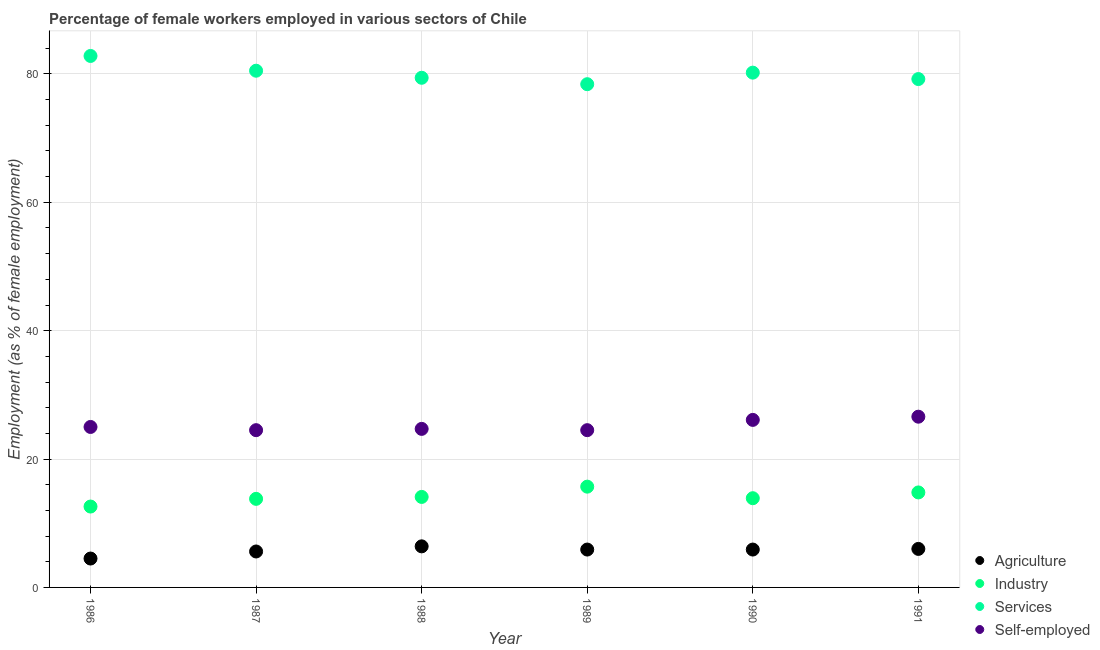What is the percentage of female workers in industry in 1987?
Provide a succinct answer. 13.8. Across all years, what is the maximum percentage of female workers in agriculture?
Offer a terse response. 6.4. Across all years, what is the minimum percentage of female workers in industry?
Provide a succinct answer. 12.6. In which year was the percentage of female workers in industry maximum?
Provide a short and direct response. 1989. What is the total percentage of female workers in industry in the graph?
Give a very brief answer. 84.9. What is the difference between the percentage of female workers in agriculture in 1986 and that in 1989?
Ensure brevity in your answer.  -1.4. What is the difference between the percentage of female workers in agriculture in 1989 and the percentage of female workers in industry in 1987?
Provide a succinct answer. -7.9. What is the average percentage of female workers in services per year?
Make the answer very short. 80.08. In the year 1987, what is the difference between the percentage of female workers in agriculture and percentage of female workers in services?
Make the answer very short. -74.9. What is the ratio of the percentage of female workers in industry in 1986 to that in 1987?
Provide a succinct answer. 0.91. Is the percentage of self employed female workers in 1986 less than that in 1989?
Your answer should be compact. No. What is the difference between the highest and the second highest percentage of self employed female workers?
Provide a succinct answer. 0.5. What is the difference between the highest and the lowest percentage of female workers in industry?
Offer a terse response. 3.1. In how many years, is the percentage of self employed female workers greater than the average percentage of self employed female workers taken over all years?
Offer a very short reply. 2. Is the sum of the percentage of female workers in industry in 1987 and 1988 greater than the maximum percentage of female workers in services across all years?
Keep it short and to the point. No. Is it the case that in every year, the sum of the percentage of female workers in agriculture and percentage of female workers in industry is greater than the percentage of female workers in services?
Ensure brevity in your answer.  No. Does the percentage of female workers in agriculture monotonically increase over the years?
Offer a terse response. No. Is the percentage of female workers in industry strictly less than the percentage of female workers in services over the years?
Provide a short and direct response. Yes. How many years are there in the graph?
Provide a short and direct response. 6. What is the difference between two consecutive major ticks on the Y-axis?
Your answer should be compact. 20. Does the graph contain any zero values?
Make the answer very short. No. What is the title of the graph?
Offer a very short reply. Percentage of female workers employed in various sectors of Chile. Does "United States" appear as one of the legend labels in the graph?
Your answer should be compact. No. What is the label or title of the Y-axis?
Provide a short and direct response. Employment (as % of female employment). What is the Employment (as % of female employment) in Industry in 1986?
Provide a succinct answer. 12.6. What is the Employment (as % of female employment) of Services in 1986?
Offer a very short reply. 82.8. What is the Employment (as % of female employment) of Agriculture in 1987?
Provide a short and direct response. 5.6. What is the Employment (as % of female employment) in Industry in 1987?
Keep it short and to the point. 13.8. What is the Employment (as % of female employment) in Services in 1987?
Make the answer very short. 80.5. What is the Employment (as % of female employment) of Agriculture in 1988?
Provide a short and direct response. 6.4. What is the Employment (as % of female employment) of Industry in 1988?
Provide a short and direct response. 14.1. What is the Employment (as % of female employment) of Services in 1988?
Your answer should be compact. 79.4. What is the Employment (as % of female employment) of Self-employed in 1988?
Ensure brevity in your answer.  24.7. What is the Employment (as % of female employment) of Agriculture in 1989?
Give a very brief answer. 5.9. What is the Employment (as % of female employment) of Industry in 1989?
Offer a terse response. 15.7. What is the Employment (as % of female employment) of Services in 1989?
Provide a short and direct response. 78.4. What is the Employment (as % of female employment) in Agriculture in 1990?
Your response must be concise. 5.9. What is the Employment (as % of female employment) of Industry in 1990?
Provide a short and direct response. 13.9. What is the Employment (as % of female employment) in Services in 1990?
Keep it short and to the point. 80.2. What is the Employment (as % of female employment) of Self-employed in 1990?
Make the answer very short. 26.1. What is the Employment (as % of female employment) of Agriculture in 1991?
Keep it short and to the point. 6. What is the Employment (as % of female employment) in Industry in 1991?
Make the answer very short. 14.8. What is the Employment (as % of female employment) in Services in 1991?
Provide a short and direct response. 79.2. What is the Employment (as % of female employment) in Self-employed in 1991?
Make the answer very short. 26.6. Across all years, what is the maximum Employment (as % of female employment) in Agriculture?
Offer a very short reply. 6.4. Across all years, what is the maximum Employment (as % of female employment) in Industry?
Ensure brevity in your answer.  15.7. Across all years, what is the maximum Employment (as % of female employment) of Services?
Your answer should be very brief. 82.8. Across all years, what is the maximum Employment (as % of female employment) of Self-employed?
Make the answer very short. 26.6. Across all years, what is the minimum Employment (as % of female employment) of Industry?
Provide a succinct answer. 12.6. Across all years, what is the minimum Employment (as % of female employment) of Services?
Give a very brief answer. 78.4. What is the total Employment (as % of female employment) in Agriculture in the graph?
Offer a terse response. 34.3. What is the total Employment (as % of female employment) in Industry in the graph?
Give a very brief answer. 84.9. What is the total Employment (as % of female employment) of Services in the graph?
Give a very brief answer. 480.5. What is the total Employment (as % of female employment) of Self-employed in the graph?
Provide a short and direct response. 151.4. What is the difference between the Employment (as % of female employment) of Industry in 1986 and that in 1987?
Ensure brevity in your answer.  -1.2. What is the difference between the Employment (as % of female employment) of Services in 1986 and that in 1987?
Your response must be concise. 2.3. What is the difference between the Employment (as % of female employment) of Industry in 1986 and that in 1988?
Keep it short and to the point. -1.5. What is the difference between the Employment (as % of female employment) of Services in 1986 and that in 1988?
Provide a short and direct response. 3.4. What is the difference between the Employment (as % of female employment) in Agriculture in 1986 and that in 1989?
Offer a very short reply. -1.4. What is the difference between the Employment (as % of female employment) of Industry in 1986 and that in 1989?
Make the answer very short. -3.1. What is the difference between the Employment (as % of female employment) in Services in 1986 and that in 1989?
Ensure brevity in your answer.  4.4. What is the difference between the Employment (as % of female employment) in Self-employed in 1986 and that in 1989?
Ensure brevity in your answer.  0.5. What is the difference between the Employment (as % of female employment) in Industry in 1986 and that in 1991?
Keep it short and to the point. -2.2. What is the difference between the Employment (as % of female employment) in Services in 1986 and that in 1991?
Make the answer very short. 3.6. What is the difference between the Employment (as % of female employment) of Self-employed in 1986 and that in 1991?
Ensure brevity in your answer.  -1.6. What is the difference between the Employment (as % of female employment) of Services in 1987 and that in 1988?
Ensure brevity in your answer.  1.1. What is the difference between the Employment (as % of female employment) of Agriculture in 1987 and that in 1989?
Ensure brevity in your answer.  -0.3. What is the difference between the Employment (as % of female employment) in Services in 1987 and that in 1989?
Your response must be concise. 2.1. What is the difference between the Employment (as % of female employment) in Self-employed in 1987 and that in 1989?
Your answer should be very brief. 0. What is the difference between the Employment (as % of female employment) in Agriculture in 1987 and that in 1990?
Provide a short and direct response. -0.3. What is the difference between the Employment (as % of female employment) in Self-employed in 1987 and that in 1990?
Your answer should be very brief. -1.6. What is the difference between the Employment (as % of female employment) in Industry in 1987 and that in 1991?
Your response must be concise. -1. What is the difference between the Employment (as % of female employment) in Services in 1987 and that in 1991?
Provide a short and direct response. 1.3. What is the difference between the Employment (as % of female employment) in Industry in 1988 and that in 1989?
Ensure brevity in your answer.  -1.6. What is the difference between the Employment (as % of female employment) of Agriculture in 1988 and that in 1990?
Your response must be concise. 0.5. What is the difference between the Employment (as % of female employment) of Services in 1988 and that in 1990?
Keep it short and to the point. -0.8. What is the difference between the Employment (as % of female employment) of Services in 1988 and that in 1991?
Offer a terse response. 0.2. What is the difference between the Employment (as % of female employment) of Self-employed in 1988 and that in 1991?
Offer a very short reply. -1.9. What is the difference between the Employment (as % of female employment) in Agriculture in 1989 and that in 1990?
Provide a short and direct response. 0. What is the difference between the Employment (as % of female employment) in Services in 1989 and that in 1990?
Your response must be concise. -1.8. What is the difference between the Employment (as % of female employment) in Self-employed in 1989 and that in 1990?
Ensure brevity in your answer.  -1.6. What is the difference between the Employment (as % of female employment) in Self-employed in 1989 and that in 1991?
Your answer should be compact. -2.1. What is the difference between the Employment (as % of female employment) in Agriculture in 1990 and that in 1991?
Ensure brevity in your answer.  -0.1. What is the difference between the Employment (as % of female employment) in Industry in 1990 and that in 1991?
Give a very brief answer. -0.9. What is the difference between the Employment (as % of female employment) in Self-employed in 1990 and that in 1991?
Your answer should be very brief. -0.5. What is the difference between the Employment (as % of female employment) of Agriculture in 1986 and the Employment (as % of female employment) of Industry in 1987?
Make the answer very short. -9.3. What is the difference between the Employment (as % of female employment) of Agriculture in 1986 and the Employment (as % of female employment) of Services in 1987?
Make the answer very short. -76. What is the difference between the Employment (as % of female employment) in Agriculture in 1986 and the Employment (as % of female employment) in Self-employed in 1987?
Provide a short and direct response. -20. What is the difference between the Employment (as % of female employment) of Industry in 1986 and the Employment (as % of female employment) of Services in 1987?
Your answer should be very brief. -67.9. What is the difference between the Employment (as % of female employment) in Industry in 1986 and the Employment (as % of female employment) in Self-employed in 1987?
Offer a very short reply. -11.9. What is the difference between the Employment (as % of female employment) of Services in 1986 and the Employment (as % of female employment) of Self-employed in 1987?
Ensure brevity in your answer.  58.3. What is the difference between the Employment (as % of female employment) of Agriculture in 1986 and the Employment (as % of female employment) of Industry in 1988?
Keep it short and to the point. -9.6. What is the difference between the Employment (as % of female employment) in Agriculture in 1986 and the Employment (as % of female employment) in Services in 1988?
Ensure brevity in your answer.  -74.9. What is the difference between the Employment (as % of female employment) in Agriculture in 1986 and the Employment (as % of female employment) in Self-employed in 1988?
Provide a short and direct response. -20.2. What is the difference between the Employment (as % of female employment) in Industry in 1986 and the Employment (as % of female employment) in Services in 1988?
Make the answer very short. -66.8. What is the difference between the Employment (as % of female employment) in Industry in 1986 and the Employment (as % of female employment) in Self-employed in 1988?
Provide a succinct answer. -12.1. What is the difference between the Employment (as % of female employment) of Services in 1986 and the Employment (as % of female employment) of Self-employed in 1988?
Provide a short and direct response. 58.1. What is the difference between the Employment (as % of female employment) of Agriculture in 1986 and the Employment (as % of female employment) of Industry in 1989?
Provide a succinct answer. -11.2. What is the difference between the Employment (as % of female employment) of Agriculture in 1986 and the Employment (as % of female employment) of Services in 1989?
Make the answer very short. -73.9. What is the difference between the Employment (as % of female employment) in Industry in 1986 and the Employment (as % of female employment) in Services in 1989?
Provide a succinct answer. -65.8. What is the difference between the Employment (as % of female employment) in Services in 1986 and the Employment (as % of female employment) in Self-employed in 1989?
Keep it short and to the point. 58.3. What is the difference between the Employment (as % of female employment) of Agriculture in 1986 and the Employment (as % of female employment) of Industry in 1990?
Provide a short and direct response. -9.4. What is the difference between the Employment (as % of female employment) in Agriculture in 1986 and the Employment (as % of female employment) in Services in 1990?
Your answer should be very brief. -75.7. What is the difference between the Employment (as % of female employment) of Agriculture in 1986 and the Employment (as % of female employment) of Self-employed in 1990?
Your answer should be very brief. -21.6. What is the difference between the Employment (as % of female employment) in Industry in 1986 and the Employment (as % of female employment) in Services in 1990?
Provide a short and direct response. -67.6. What is the difference between the Employment (as % of female employment) in Services in 1986 and the Employment (as % of female employment) in Self-employed in 1990?
Your response must be concise. 56.7. What is the difference between the Employment (as % of female employment) in Agriculture in 1986 and the Employment (as % of female employment) in Services in 1991?
Offer a very short reply. -74.7. What is the difference between the Employment (as % of female employment) in Agriculture in 1986 and the Employment (as % of female employment) in Self-employed in 1991?
Offer a terse response. -22.1. What is the difference between the Employment (as % of female employment) of Industry in 1986 and the Employment (as % of female employment) of Services in 1991?
Your response must be concise. -66.6. What is the difference between the Employment (as % of female employment) in Industry in 1986 and the Employment (as % of female employment) in Self-employed in 1991?
Your answer should be very brief. -14. What is the difference between the Employment (as % of female employment) in Services in 1986 and the Employment (as % of female employment) in Self-employed in 1991?
Your response must be concise. 56.2. What is the difference between the Employment (as % of female employment) of Agriculture in 1987 and the Employment (as % of female employment) of Services in 1988?
Offer a terse response. -73.8. What is the difference between the Employment (as % of female employment) of Agriculture in 1987 and the Employment (as % of female employment) of Self-employed in 1988?
Provide a short and direct response. -19.1. What is the difference between the Employment (as % of female employment) in Industry in 1987 and the Employment (as % of female employment) in Services in 1988?
Keep it short and to the point. -65.6. What is the difference between the Employment (as % of female employment) in Services in 1987 and the Employment (as % of female employment) in Self-employed in 1988?
Provide a succinct answer. 55.8. What is the difference between the Employment (as % of female employment) in Agriculture in 1987 and the Employment (as % of female employment) in Services in 1989?
Give a very brief answer. -72.8. What is the difference between the Employment (as % of female employment) in Agriculture in 1987 and the Employment (as % of female employment) in Self-employed in 1989?
Offer a very short reply. -18.9. What is the difference between the Employment (as % of female employment) of Industry in 1987 and the Employment (as % of female employment) of Services in 1989?
Keep it short and to the point. -64.6. What is the difference between the Employment (as % of female employment) in Industry in 1987 and the Employment (as % of female employment) in Self-employed in 1989?
Ensure brevity in your answer.  -10.7. What is the difference between the Employment (as % of female employment) in Agriculture in 1987 and the Employment (as % of female employment) in Industry in 1990?
Your response must be concise. -8.3. What is the difference between the Employment (as % of female employment) of Agriculture in 1987 and the Employment (as % of female employment) of Services in 1990?
Make the answer very short. -74.6. What is the difference between the Employment (as % of female employment) in Agriculture in 1987 and the Employment (as % of female employment) in Self-employed in 1990?
Your answer should be compact. -20.5. What is the difference between the Employment (as % of female employment) of Industry in 1987 and the Employment (as % of female employment) of Services in 1990?
Ensure brevity in your answer.  -66.4. What is the difference between the Employment (as % of female employment) of Services in 1987 and the Employment (as % of female employment) of Self-employed in 1990?
Your response must be concise. 54.4. What is the difference between the Employment (as % of female employment) in Agriculture in 1987 and the Employment (as % of female employment) in Industry in 1991?
Offer a very short reply. -9.2. What is the difference between the Employment (as % of female employment) in Agriculture in 1987 and the Employment (as % of female employment) in Services in 1991?
Ensure brevity in your answer.  -73.6. What is the difference between the Employment (as % of female employment) of Agriculture in 1987 and the Employment (as % of female employment) of Self-employed in 1991?
Ensure brevity in your answer.  -21. What is the difference between the Employment (as % of female employment) of Industry in 1987 and the Employment (as % of female employment) of Services in 1991?
Ensure brevity in your answer.  -65.4. What is the difference between the Employment (as % of female employment) of Services in 1987 and the Employment (as % of female employment) of Self-employed in 1991?
Provide a short and direct response. 53.9. What is the difference between the Employment (as % of female employment) of Agriculture in 1988 and the Employment (as % of female employment) of Industry in 1989?
Your response must be concise. -9.3. What is the difference between the Employment (as % of female employment) of Agriculture in 1988 and the Employment (as % of female employment) of Services in 1989?
Your response must be concise. -72. What is the difference between the Employment (as % of female employment) of Agriculture in 1988 and the Employment (as % of female employment) of Self-employed in 1989?
Offer a terse response. -18.1. What is the difference between the Employment (as % of female employment) of Industry in 1988 and the Employment (as % of female employment) of Services in 1989?
Provide a short and direct response. -64.3. What is the difference between the Employment (as % of female employment) in Services in 1988 and the Employment (as % of female employment) in Self-employed in 1989?
Make the answer very short. 54.9. What is the difference between the Employment (as % of female employment) in Agriculture in 1988 and the Employment (as % of female employment) in Services in 1990?
Provide a succinct answer. -73.8. What is the difference between the Employment (as % of female employment) in Agriculture in 1988 and the Employment (as % of female employment) in Self-employed in 1990?
Give a very brief answer. -19.7. What is the difference between the Employment (as % of female employment) of Industry in 1988 and the Employment (as % of female employment) of Services in 1990?
Give a very brief answer. -66.1. What is the difference between the Employment (as % of female employment) of Services in 1988 and the Employment (as % of female employment) of Self-employed in 1990?
Your response must be concise. 53.3. What is the difference between the Employment (as % of female employment) of Agriculture in 1988 and the Employment (as % of female employment) of Services in 1991?
Ensure brevity in your answer.  -72.8. What is the difference between the Employment (as % of female employment) in Agriculture in 1988 and the Employment (as % of female employment) in Self-employed in 1991?
Make the answer very short. -20.2. What is the difference between the Employment (as % of female employment) in Industry in 1988 and the Employment (as % of female employment) in Services in 1991?
Your response must be concise. -65.1. What is the difference between the Employment (as % of female employment) of Services in 1988 and the Employment (as % of female employment) of Self-employed in 1991?
Offer a terse response. 52.8. What is the difference between the Employment (as % of female employment) of Agriculture in 1989 and the Employment (as % of female employment) of Services in 1990?
Offer a very short reply. -74.3. What is the difference between the Employment (as % of female employment) in Agriculture in 1989 and the Employment (as % of female employment) in Self-employed in 1990?
Your response must be concise. -20.2. What is the difference between the Employment (as % of female employment) in Industry in 1989 and the Employment (as % of female employment) in Services in 1990?
Keep it short and to the point. -64.5. What is the difference between the Employment (as % of female employment) in Services in 1989 and the Employment (as % of female employment) in Self-employed in 1990?
Offer a very short reply. 52.3. What is the difference between the Employment (as % of female employment) of Agriculture in 1989 and the Employment (as % of female employment) of Industry in 1991?
Provide a succinct answer. -8.9. What is the difference between the Employment (as % of female employment) in Agriculture in 1989 and the Employment (as % of female employment) in Services in 1991?
Ensure brevity in your answer.  -73.3. What is the difference between the Employment (as % of female employment) in Agriculture in 1989 and the Employment (as % of female employment) in Self-employed in 1991?
Your answer should be compact. -20.7. What is the difference between the Employment (as % of female employment) of Industry in 1989 and the Employment (as % of female employment) of Services in 1991?
Make the answer very short. -63.5. What is the difference between the Employment (as % of female employment) in Industry in 1989 and the Employment (as % of female employment) in Self-employed in 1991?
Keep it short and to the point. -10.9. What is the difference between the Employment (as % of female employment) in Services in 1989 and the Employment (as % of female employment) in Self-employed in 1991?
Keep it short and to the point. 51.8. What is the difference between the Employment (as % of female employment) in Agriculture in 1990 and the Employment (as % of female employment) in Industry in 1991?
Make the answer very short. -8.9. What is the difference between the Employment (as % of female employment) in Agriculture in 1990 and the Employment (as % of female employment) in Services in 1991?
Offer a very short reply. -73.3. What is the difference between the Employment (as % of female employment) in Agriculture in 1990 and the Employment (as % of female employment) in Self-employed in 1991?
Keep it short and to the point. -20.7. What is the difference between the Employment (as % of female employment) of Industry in 1990 and the Employment (as % of female employment) of Services in 1991?
Offer a very short reply. -65.3. What is the difference between the Employment (as % of female employment) of Services in 1990 and the Employment (as % of female employment) of Self-employed in 1991?
Give a very brief answer. 53.6. What is the average Employment (as % of female employment) of Agriculture per year?
Provide a short and direct response. 5.72. What is the average Employment (as % of female employment) in Industry per year?
Offer a terse response. 14.15. What is the average Employment (as % of female employment) in Services per year?
Ensure brevity in your answer.  80.08. What is the average Employment (as % of female employment) of Self-employed per year?
Make the answer very short. 25.23. In the year 1986, what is the difference between the Employment (as % of female employment) in Agriculture and Employment (as % of female employment) in Industry?
Your answer should be very brief. -8.1. In the year 1986, what is the difference between the Employment (as % of female employment) of Agriculture and Employment (as % of female employment) of Services?
Offer a very short reply. -78.3. In the year 1986, what is the difference between the Employment (as % of female employment) in Agriculture and Employment (as % of female employment) in Self-employed?
Provide a short and direct response. -20.5. In the year 1986, what is the difference between the Employment (as % of female employment) of Industry and Employment (as % of female employment) of Services?
Keep it short and to the point. -70.2. In the year 1986, what is the difference between the Employment (as % of female employment) of Services and Employment (as % of female employment) of Self-employed?
Give a very brief answer. 57.8. In the year 1987, what is the difference between the Employment (as % of female employment) in Agriculture and Employment (as % of female employment) in Services?
Make the answer very short. -74.9. In the year 1987, what is the difference between the Employment (as % of female employment) of Agriculture and Employment (as % of female employment) of Self-employed?
Provide a succinct answer. -18.9. In the year 1987, what is the difference between the Employment (as % of female employment) in Industry and Employment (as % of female employment) in Services?
Give a very brief answer. -66.7. In the year 1988, what is the difference between the Employment (as % of female employment) in Agriculture and Employment (as % of female employment) in Industry?
Ensure brevity in your answer.  -7.7. In the year 1988, what is the difference between the Employment (as % of female employment) of Agriculture and Employment (as % of female employment) of Services?
Your answer should be compact. -73. In the year 1988, what is the difference between the Employment (as % of female employment) of Agriculture and Employment (as % of female employment) of Self-employed?
Give a very brief answer. -18.3. In the year 1988, what is the difference between the Employment (as % of female employment) in Industry and Employment (as % of female employment) in Services?
Offer a terse response. -65.3. In the year 1988, what is the difference between the Employment (as % of female employment) of Services and Employment (as % of female employment) of Self-employed?
Give a very brief answer. 54.7. In the year 1989, what is the difference between the Employment (as % of female employment) of Agriculture and Employment (as % of female employment) of Industry?
Offer a terse response. -9.8. In the year 1989, what is the difference between the Employment (as % of female employment) in Agriculture and Employment (as % of female employment) in Services?
Your answer should be very brief. -72.5. In the year 1989, what is the difference between the Employment (as % of female employment) in Agriculture and Employment (as % of female employment) in Self-employed?
Provide a succinct answer. -18.6. In the year 1989, what is the difference between the Employment (as % of female employment) in Industry and Employment (as % of female employment) in Services?
Ensure brevity in your answer.  -62.7. In the year 1989, what is the difference between the Employment (as % of female employment) of Services and Employment (as % of female employment) of Self-employed?
Provide a succinct answer. 53.9. In the year 1990, what is the difference between the Employment (as % of female employment) of Agriculture and Employment (as % of female employment) of Industry?
Keep it short and to the point. -8. In the year 1990, what is the difference between the Employment (as % of female employment) in Agriculture and Employment (as % of female employment) in Services?
Give a very brief answer. -74.3. In the year 1990, what is the difference between the Employment (as % of female employment) in Agriculture and Employment (as % of female employment) in Self-employed?
Ensure brevity in your answer.  -20.2. In the year 1990, what is the difference between the Employment (as % of female employment) of Industry and Employment (as % of female employment) of Services?
Make the answer very short. -66.3. In the year 1990, what is the difference between the Employment (as % of female employment) in Industry and Employment (as % of female employment) in Self-employed?
Offer a very short reply. -12.2. In the year 1990, what is the difference between the Employment (as % of female employment) in Services and Employment (as % of female employment) in Self-employed?
Offer a very short reply. 54.1. In the year 1991, what is the difference between the Employment (as % of female employment) in Agriculture and Employment (as % of female employment) in Industry?
Make the answer very short. -8.8. In the year 1991, what is the difference between the Employment (as % of female employment) in Agriculture and Employment (as % of female employment) in Services?
Provide a short and direct response. -73.2. In the year 1991, what is the difference between the Employment (as % of female employment) of Agriculture and Employment (as % of female employment) of Self-employed?
Make the answer very short. -20.6. In the year 1991, what is the difference between the Employment (as % of female employment) in Industry and Employment (as % of female employment) in Services?
Provide a short and direct response. -64.4. In the year 1991, what is the difference between the Employment (as % of female employment) of Industry and Employment (as % of female employment) of Self-employed?
Provide a short and direct response. -11.8. In the year 1991, what is the difference between the Employment (as % of female employment) in Services and Employment (as % of female employment) in Self-employed?
Offer a terse response. 52.6. What is the ratio of the Employment (as % of female employment) of Agriculture in 1986 to that in 1987?
Give a very brief answer. 0.8. What is the ratio of the Employment (as % of female employment) of Services in 1986 to that in 1987?
Provide a short and direct response. 1.03. What is the ratio of the Employment (as % of female employment) of Self-employed in 1986 to that in 1987?
Offer a very short reply. 1.02. What is the ratio of the Employment (as % of female employment) of Agriculture in 1986 to that in 1988?
Keep it short and to the point. 0.7. What is the ratio of the Employment (as % of female employment) of Industry in 1986 to that in 1988?
Your answer should be compact. 0.89. What is the ratio of the Employment (as % of female employment) of Services in 1986 to that in 1988?
Provide a short and direct response. 1.04. What is the ratio of the Employment (as % of female employment) of Self-employed in 1986 to that in 1988?
Make the answer very short. 1.01. What is the ratio of the Employment (as % of female employment) in Agriculture in 1986 to that in 1989?
Your answer should be compact. 0.76. What is the ratio of the Employment (as % of female employment) of Industry in 1986 to that in 1989?
Your answer should be compact. 0.8. What is the ratio of the Employment (as % of female employment) of Services in 1986 to that in 1989?
Keep it short and to the point. 1.06. What is the ratio of the Employment (as % of female employment) of Self-employed in 1986 to that in 1989?
Ensure brevity in your answer.  1.02. What is the ratio of the Employment (as % of female employment) in Agriculture in 1986 to that in 1990?
Keep it short and to the point. 0.76. What is the ratio of the Employment (as % of female employment) of Industry in 1986 to that in 1990?
Keep it short and to the point. 0.91. What is the ratio of the Employment (as % of female employment) in Services in 1986 to that in 1990?
Your response must be concise. 1.03. What is the ratio of the Employment (as % of female employment) in Self-employed in 1986 to that in 1990?
Ensure brevity in your answer.  0.96. What is the ratio of the Employment (as % of female employment) in Agriculture in 1986 to that in 1991?
Offer a very short reply. 0.75. What is the ratio of the Employment (as % of female employment) in Industry in 1986 to that in 1991?
Give a very brief answer. 0.85. What is the ratio of the Employment (as % of female employment) in Services in 1986 to that in 1991?
Provide a succinct answer. 1.05. What is the ratio of the Employment (as % of female employment) of Self-employed in 1986 to that in 1991?
Make the answer very short. 0.94. What is the ratio of the Employment (as % of female employment) of Agriculture in 1987 to that in 1988?
Keep it short and to the point. 0.88. What is the ratio of the Employment (as % of female employment) in Industry in 1987 to that in 1988?
Provide a short and direct response. 0.98. What is the ratio of the Employment (as % of female employment) of Services in 1987 to that in 1988?
Offer a terse response. 1.01. What is the ratio of the Employment (as % of female employment) in Agriculture in 1987 to that in 1989?
Your answer should be very brief. 0.95. What is the ratio of the Employment (as % of female employment) of Industry in 1987 to that in 1989?
Your response must be concise. 0.88. What is the ratio of the Employment (as % of female employment) of Services in 1987 to that in 1989?
Your answer should be very brief. 1.03. What is the ratio of the Employment (as % of female employment) of Agriculture in 1987 to that in 1990?
Provide a succinct answer. 0.95. What is the ratio of the Employment (as % of female employment) of Industry in 1987 to that in 1990?
Make the answer very short. 0.99. What is the ratio of the Employment (as % of female employment) in Services in 1987 to that in 1990?
Give a very brief answer. 1. What is the ratio of the Employment (as % of female employment) in Self-employed in 1987 to that in 1990?
Keep it short and to the point. 0.94. What is the ratio of the Employment (as % of female employment) in Industry in 1987 to that in 1991?
Your response must be concise. 0.93. What is the ratio of the Employment (as % of female employment) of Services in 1987 to that in 1991?
Offer a very short reply. 1.02. What is the ratio of the Employment (as % of female employment) in Self-employed in 1987 to that in 1991?
Keep it short and to the point. 0.92. What is the ratio of the Employment (as % of female employment) in Agriculture in 1988 to that in 1989?
Provide a succinct answer. 1.08. What is the ratio of the Employment (as % of female employment) of Industry in 1988 to that in 1989?
Your answer should be compact. 0.9. What is the ratio of the Employment (as % of female employment) of Services in 1988 to that in 1989?
Provide a short and direct response. 1.01. What is the ratio of the Employment (as % of female employment) in Self-employed in 1988 to that in 1989?
Provide a succinct answer. 1.01. What is the ratio of the Employment (as % of female employment) of Agriculture in 1988 to that in 1990?
Your response must be concise. 1.08. What is the ratio of the Employment (as % of female employment) in Industry in 1988 to that in 1990?
Give a very brief answer. 1.01. What is the ratio of the Employment (as % of female employment) of Self-employed in 1988 to that in 1990?
Your answer should be very brief. 0.95. What is the ratio of the Employment (as % of female employment) in Agriculture in 1988 to that in 1991?
Provide a succinct answer. 1.07. What is the ratio of the Employment (as % of female employment) in Industry in 1988 to that in 1991?
Your response must be concise. 0.95. What is the ratio of the Employment (as % of female employment) of Services in 1988 to that in 1991?
Make the answer very short. 1. What is the ratio of the Employment (as % of female employment) of Industry in 1989 to that in 1990?
Your response must be concise. 1.13. What is the ratio of the Employment (as % of female employment) of Services in 1989 to that in 1990?
Your response must be concise. 0.98. What is the ratio of the Employment (as % of female employment) in Self-employed in 1989 to that in 1990?
Ensure brevity in your answer.  0.94. What is the ratio of the Employment (as % of female employment) of Agriculture in 1989 to that in 1991?
Provide a short and direct response. 0.98. What is the ratio of the Employment (as % of female employment) of Industry in 1989 to that in 1991?
Offer a terse response. 1.06. What is the ratio of the Employment (as % of female employment) of Self-employed in 1989 to that in 1991?
Provide a short and direct response. 0.92. What is the ratio of the Employment (as % of female employment) in Agriculture in 1990 to that in 1991?
Give a very brief answer. 0.98. What is the ratio of the Employment (as % of female employment) of Industry in 1990 to that in 1991?
Your answer should be compact. 0.94. What is the ratio of the Employment (as % of female employment) in Services in 1990 to that in 1991?
Keep it short and to the point. 1.01. What is the ratio of the Employment (as % of female employment) of Self-employed in 1990 to that in 1991?
Your answer should be compact. 0.98. What is the difference between the highest and the second highest Employment (as % of female employment) in Industry?
Offer a terse response. 0.9. What is the difference between the highest and the second highest Employment (as % of female employment) in Self-employed?
Keep it short and to the point. 0.5. What is the difference between the highest and the lowest Employment (as % of female employment) in Agriculture?
Offer a very short reply. 1.9. 